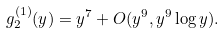Convert formula to latex. <formula><loc_0><loc_0><loc_500><loc_500>g _ { 2 } ^ { ( 1 ) } ( y ) = y ^ { 7 } + O ( y ^ { 9 } , y ^ { 9 } \log y ) .</formula> 